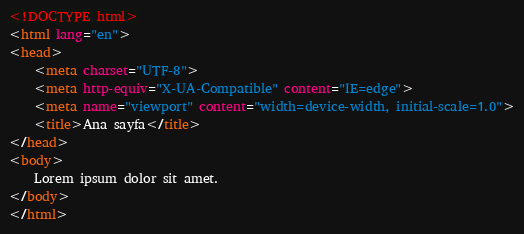<code> <loc_0><loc_0><loc_500><loc_500><_HTML_><!DOCTYPE html>
<html lang="en">
<head>
    <meta charset="UTF-8">
    <meta http-equiv="X-UA-Compatible" content="IE=edge">
    <meta name="viewport" content="width=device-width, initial-scale=1.0">
    <title>Ana sayfa</title>
</head>
<body>
    Lorem ipsum dolor sit amet.
</body>
</html></code> 